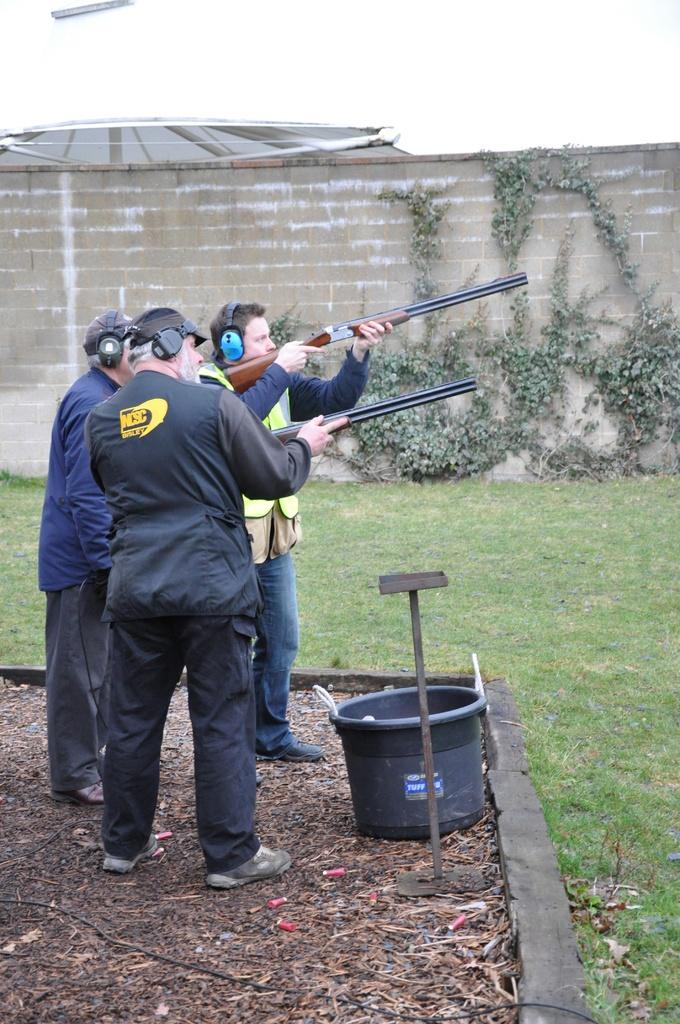What are the men in the image doing? The men are standing on the ground and holding guns in their hands. What can be seen in the background of the image? There is a wall, creepers, ground, and a bin visible in the background. How many men are present in the image? The number of men is not specified, but there are at least two men holding guns. What might the men be guarding or protecting in the image? It is not clear from the image what the men might be guarding or protecting. What type of mailbox can be seen in the image? There is no mailbox present in the image. What unit of measurement is used to describe the height of the wall in the image? The height of the wall is not specified in the image, and therefore no unit of measurement can be determined. 